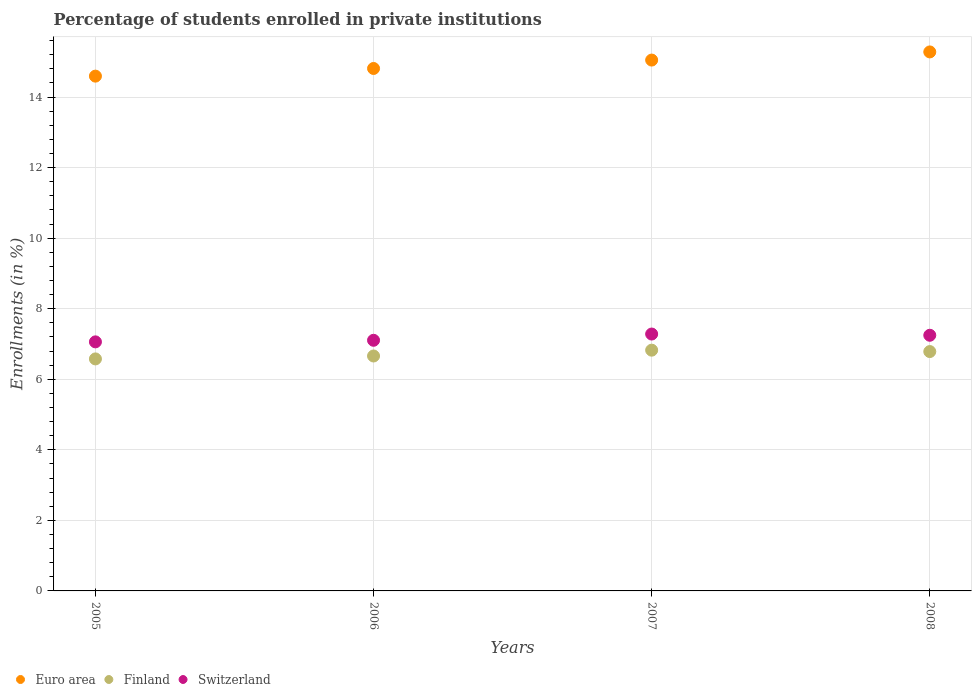What is the percentage of trained teachers in Euro area in 2005?
Provide a succinct answer. 14.59. Across all years, what is the maximum percentage of trained teachers in Switzerland?
Give a very brief answer. 7.28. Across all years, what is the minimum percentage of trained teachers in Finland?
Provide a short and direct response. 6.58. What is the total percentage of trained teachers in Finland in the graph?
Your response must be concise. 26.85. What is the difference between the percentage of trained teachers in Finland in 2006 and that in 2008?
Provide a short and direct response. -0.13. What is the difference between the percentage of trained teachers in Euro area in 2007 and the percentage of trained teachers in Switzerland in 2008?
Offer a terse response. 7.8. What is the average percentage of trained teachers in Euro area per year?
Your answer should be very brief. 14.93. In the year 2006, what is the difference between the percentage of trained teachers in Finland and percentage of trained teachers in Switzerland?
Ensure brevity in your answer.  -0.45. In how many years, is the percentage of trained teachers in Switzerland greater than 2.4 %?
Your response must be concise. 4. What is the ratio of the percentage of trained teachers in Euro area in 2006 to that in 2007?
Offer a terse response. 0.98. Is the percentage of trained teachers in Euro area in 2006 less than that in 2008?
Ensure brevity in your answer.  Yes. What is the difference between the highest and the second highest percentage of trained teachers in Switzerland?
Your answer should be compact. 0.03. What is the difference between the highest and the lowest percentage of trained teachers in Finland?
Your response must be concise. 0.25. In how many years, is the percentage of trained teachers in Switzerland greater than the average percentage of trained teachers in Switzerland taken over all years?
Offer a very short reply. 2. Is the sum of the percentage of trained teachers in Finland in 2005 and 2006 greater than the maximum percentage of trained teachers in Switzerland across all years?
Your response must be concise. Yes. How many dotlines are there?
Offer a very short reply. 3. How many years are there in the graph?
Make the answer very short. 4. Are the values on the major ticks of Y-axis written in scientific E-notation?
Your answer should be compact. No. Where does the legend appear in the graph?
Your answer should be compact. Bottom left. What is the title of the graph?
Give a very brief answer. Percentage of students enrolled in private institutions. Does "Qatar" appear as one of the legend labels in the graph?
Offer a very short reply. No. What is the label or title of the X-axis?
Your answer should be compact. Years. What is the label or title of the Y-axis?
Offer a very short reply. Enrollments (in %). What is the Enrollments (in %) in Euro area in 2005?
Make the answer very short. 14.59. What is the Enrollments (in %) in Finland in 2005?
Your answer should be compact. 6.58. What is the Enrollments (in %) of Switzerland in 2005?
Offer a terse response. 7.06. What is the Enrollments (in %) in Euro area in 2006?
Your answer should be very brief. 14.81. What is the Enrollments (in %) of Finland in 2006?
Your answer should be very brief. 6.66. What is the Enrollments (in %) in Switzerland in 2006?
Ensure brevity in your answer.  7.1. What is the Enrollments (in %) of Euro area in 2007?
Give a very brief answer. 15.05. What is the Enrollments (in %) in Finland in 2007?
Give a very brief answer. 6.82. What is the Enrollments (in %) in Switzerland in 2007?
Offer a very short reply. 7.28. What is the Enrollments (in %) of Euro area in 2008?
Provide a short and direct response. 15.28. What is the Enrollments (in %) of Finland in 2008?
Your response must be concise. 6.79. What is the Enrollments (in %) of Switzerland in 2008?
Ensure brevity in your answer.  7.25. Across all years, what is the maximum Enrollments (in %) in Euro area?
Make the answer very short. 15.28. Across all years, what is the maximum Enrollments (in %) in Finland?
Your answer should be compact. 6.82. Across all years, what is the maximum Enrollments (in %) in Switzerland?
Ensure brevity in your answer.  7.28. Across all years, what is the minimum Enrollments (in %) in Euro area?
Provide a short and direct response. 14.59. Across all years, what is the minimum Enrollments (in %) in Finland?
Your answer should be compact. 6.58. Across all years, what is the minimum Enrollments (in %) of Switzerland?
Make the answer very short. 7.06. What is the total Enrollments (in %) of Euro area in the graph?
Make the answer very short. 59.73. What is the total Enrollments (in %) in Finland in the graph?
Offer a terse response. 26.85. What is the total Enrollments (in %) of Switzerland in the graph?
Your answer should be very brief. 28.69. What is the difference between the Enrollments (in %) in Euro area in 2005 and that in 2006?
Offer a very short reply. -0.22. What is the difference between the Enrollments (in %) in Finland in 2005 and that in 2006?
Give a very brief answer. -0.08. What is the difference between the Enrollments (in %) of Switzerland in 2005 and that in 2006?
Provide a short and direct response. -0.04. What is the difference between the Enrollments (in %) in Euro area in 2005 and that in 2007?
Offer a terse response. -0.46. What is the difference between the Enrollments (in %) of Finland in 2005 and that in 2007?
Offer a terse response. -0.25. What is the difference between the Enrollments (in %) in Switzerland in 2005 and that in 2007?
Your answer should be compact. -0.22. What is the difference between the Enrollments (in %) in Euro area in 2005 and that in 2008?
Provide a succinct answer. -0.69. What is the difference between the Enrollments (in %) in Finland in 2005 and that in 2008?
Offer a very short reply. -0.21. What is the difference between the Enrollments (in %) in Switzerland in 2005 and that in 2008?
Offer a very short reply. -0.19. What is the difference between the Enrollments (in %) of Euro area in 2006 and that in 2007?
Your answer should be compact. -0.24. What is the difference between the Enrollments (in %) of Finland in 2006 and that in 2007?
Ensure brevity in your answer.  -0.17. What is the difference between the Enrollments (in %) of Switzerland in 2006 and that in 2007?
Make the answer very short. -0.18. What is the difference between the Enrollments (in %) of Euro area in 2006 and that in 2008?
Provide a short and direct response. -0.47. What is the difference between the Enrollments (in %) of Finland in 2006 and that in 2008?
Provide a short and direct response. -0.13. What is the difference between the Enrollments (in %) of Switzerland in 2006 and that in 2008?
Your response must be concise. -0.14. What is the difference between the Enrollments (in %) of Euro area in 2007 and that in 2008?
Your response must be concise. -0.23. What is the difference between the Enrollments (in %) of Finland in 2007 and that in 2008?
Provide a succinct answer. 0.04. What is the difference between the Enrollments (in %) of Switzerland in 2007 and that in 2008?
Provide a short and direct response. 0.04. What is the difference between the Enrollments (in %) in Euro area in 2005 and the Enrollments (in %) in Finland in 2006?
Make the answer very short. 7.93. What is the difference between the Enrollments (in %) of Euro area in 2005 and the Enrollments (in %) of Switzerland in 2006?
Offer a terse response. 7.49. What is the difference between the Enrollments (in %) in Finland in 2005 and the Enrollments (in %) in Switzerland in 2006?
Your answer should be compact. -0.53. What is the difference between the Enrollments (in %) of Euro area in 2005 and the Enrollments (in %) of Finland in 2007?
Offer a terse response. 7.77. What is the difference between the Enrollments (in %) in Euro area in 2005 and the Enrollments (in %) in Switzerland in 2007?
Provide a short and direct response. 7.31. What is the difference between the Enrollments (in %) in Finland in 2005 and the Enrollments (in %) in Switzerland in 2007?
Your answer should be very brief. -0.71. What is the difference between the Enrollments (in %) of Euro area in 2005 and the Enrollments (in %) of Finland in 2008?
Your answer should be very brief. 7.81. What is the difference between the Enrollments (in %) of Euro area in 2005 and the Enrollments (in %) of Switzerland in 2008?
Your answer should be compact. 7.35. What is the difference between the Enrollments (in %) of Finland in 2005 and the Enrollments (in %) of Switzerland in 2008?
Make the answer very short. -0.67. What is the difference between the Enrollments (in %) in Euro area in 2006 and the Enrollments (in %) in Finland in 2007?
Provide a succinct answer. 7.99. What is the difference between the Enrollments (in %) in Euro area in 2006 and the Enrollments (in %) in Switzerland in 2007?
Offer a terse response. 7.53. What is the difference between the Enrollments (in %) of Finland in 2006 and the Enrollments (in %) of Switzerland in 2007?
Keep it short and to the point. -0.62. What is the difference between the Enrollments (in %) of Euro area in 2006 and the Enrollments (in %) of Finland in 2008?
Keep it short and to the point. 8.02. What is the difference between the Enrollments (in %) of Euro area in 2006 and the Enrollments (in %) of Switzerland in 2008?
Your response must be concise. 7.56. What is the difference between the Enrollments (in %) of Finland in 2006 and the Enrollments (in %) of Switzerland in 2008?
Your answer should be very brief. -0.59. What is the difference between the Enrollments (in %) in Euro area in 2007 and the Enrollments (in %) in Finland in 2008?
Your answer should be very brief. 8.26. What is the difference between the Enrollments (in %) in Euro area in 2007 and the Enrollments (in %) in Switzerland in 2008?
Make the answer very short. 7.8. What is the difference between the Enrollments (in %) of Finland in 2007 and the Enrollments (in %) of Switzerland in 2008?
Keep it short and to the point. -0.42. What is the average Enrollments (in %) in Euro area per year?
Ensure brevity in your answer.  14.93. What is the average Enrollments (in %) of Finland per year?
Your response must be concise. 6.71. What is the average Enrollments (in %) of Switzerland per year?
Your answer should be very brief. 7.17. In the year 2005, what is the difference between the Enrollments (in %) in Euro area and Enrollments (in %) in Finland?
Your answer should be very brief. 8.02. In the year 2005, what is the difference between the Enrollments (in %) of Euro area and Enrollments (in %) of Switzerland?
Give a very brief answer. 7.53. In the year 2005, what is the difference between the Enrollments (in %) in Finland and Enrollments (in %) in Switzerland?
Ensure brevity in your answer.  -0.48. In the year 2006, what is the difference between the Enrollments (in %) of Euro area and Enrollments (in %) of Finland?
Ensure brevity in your answer.  8.15. In the year 2006, what is the difference between the Enrollments (in %) of Euro area and Enrollments (in %) of Switzerland?
Ensure brevity in your answer.  7.71. In the year 2006, what is the difference between the Enrollments (in %) in Finland and Enrollments (in %) in Switzerland?
Provide a short and direct response. -0.45. In the year 2007, what is the difference between the Enrollments (in %) in Euro area and Enrollments (in %) in Finland?
Make the answer very short. 8.22. In the year 2007, what is the difference between the Enrollments (in %) of Euro area and Enrollments (in %) of Switzerland?
Offer a terse response. 7.77. In the year 2007, what is the difference between the Enrollments (in %) in Finland and Enrollments (in %) in Switzerland?
Your response must be concise. -0.46. In the year 2008, what is the difference between the Enrollments (in %) of Euro area and Enrollments (in %) of Finland?
Ensure brevity in your answer.  8.49. In the year 2008, what is the difference between the Enrollments (in %) in Euro area and Enrollments (in %) in Switzerland?
Give a very brief answer. 8.03. In the year 2008, what is the difference between the Enrollments (in %) in Finland and Enrollments (in %) in Switzerland?
Your answer should be very brief. -0.46. What is the ratio of the Enrollments (in %) of Euro area in 2005 to that in 2006?
Your answer should be compact. 0.99. What is the ratio of the Enrollments (in %) in Finland in 2005 to that in 2006?
Give a very brief answer. 0.99. What is the ratio of the Enrollments (in %) in Euro area in 2005 to that in 2007?
Offer a very short reply. 0.97. What is the ratio of the Enrollments (in %) in Finland in 2005 to that in 2007?
Keep it short and to the point. 0.96. What is the ratio of the Enrollments (in %) in Switzerland in 2005 to that in 2007?
Provide a short and direct response. 0.97. What is the ratio of the Enrollments (in %) in Euro area in 2005 to that in 2008?
Offer a terse response. 0.96. What is the ratio of the Enrollments (in %) in Finland in 2005 to that in 2008?
Offer a terse response. 0.97. What is the ratio of the Enrollments (in %) in Switzerland in 2005 to that in 2008?
Make the answer very short. 0.97. What is the ratio of the Enrollments (in %) in Euro area in 2006 to that in 2007?
Your answer should be compact. 0.98. What is the ratio of the Enrollments (in %) in Finland in 2006 to that in 2007?
Provide a succinct answer. 0.98. What is the ratio of the Enrollments (in %) in Switzerland in 2006 to that in 2007?
Your response must be concise. 0.98. What is the ratio of the Enrollments (in %) of Euro area in 2006 to that in 2008?
Your response must be concise. 0.97. What is the ratio of the Enrollments (in %) in Finland in 2006 to that in 2008?
Ensure brevity in your answer.  0.98. What is the ratio of the Enrollments (in %) in Switzerland in 2006 to that in 2008?
Your answer should be compact. 0.98. What is the ratio of the Enrollments (in %) in Euro area in 2007 to that in 2008?
Make the answer very short. 0.98. What is the difference between the highest and the second highest Enrollments (in %) of Euro area?
Provide a short and direct response. 0.23. What is the difference between the highest and the second highest Enrollments (in %) of Finland?
Provide a succinct answer. 0.04. What is the difference between the highest and the second highest Enrollments (in %) in Switzerland?
Offer a very short reply. 0.04. What is the difference between the highest and the lowest Enrollments (in %) of Euro area?
Provide a succinct answer. 0.69. What is the difference between the highest and the lowest Enrollments (in %) of Finland?
Keep it short and to the point. 0.25. What is the difference between the highest and the lowest Enrollments (in %) in Switzerland?
Your answer should be compact. 0.22. 